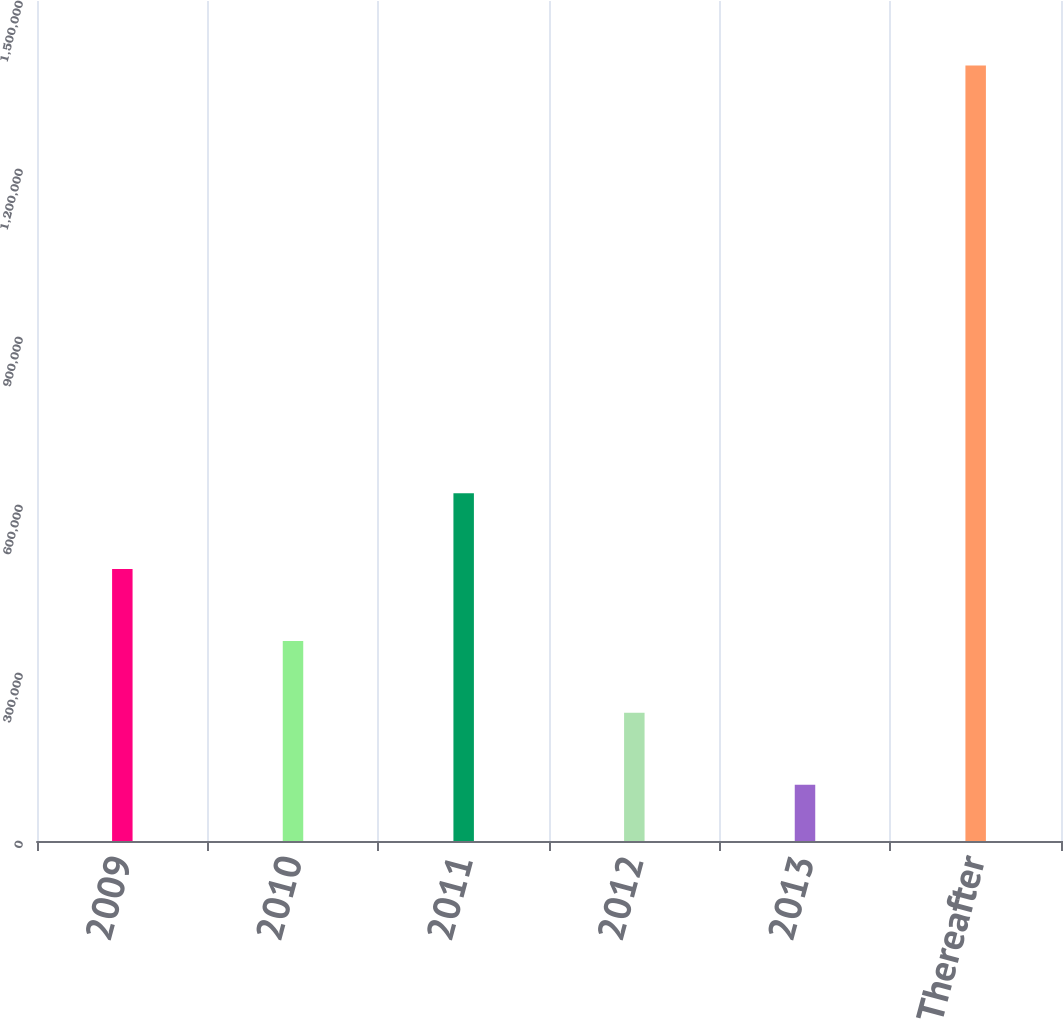Convert chart. <chart><loc_0><loc_0><loc_500><loc_500><bar_chart><fcel>2009<fcel>2010<fcel>2011<fcel>2012<fcel>2013<fcel>Thereafter<nl><fcel>485792<fcel>357340<fcel>620808<fcel>228888<fcel>100436<fcel>1.38496e+06<nl></chart> 